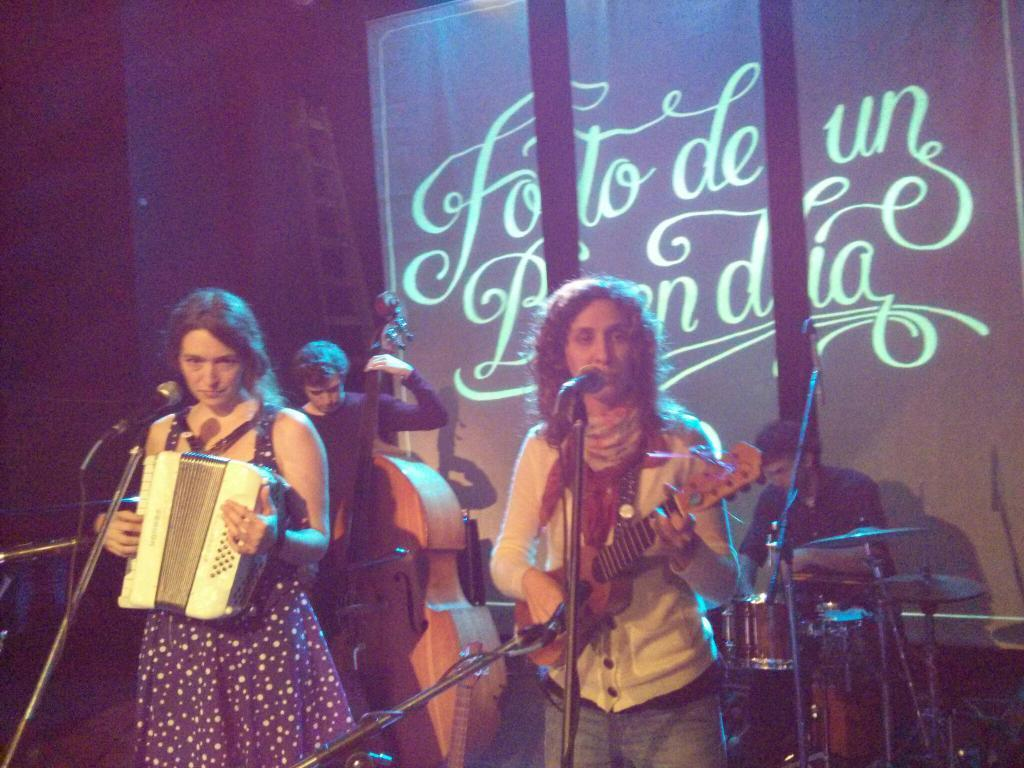How many people are in the image? There are people in the image, but the exact number is not specified. What are the people doing in the image? The people are standing in the image. What are the people holding in their hands? The people are holding musical instruments in their hands. What type of glove can be seen on the person's hand in the image? There is no glove present on any person's hand in the image. What type of substance is being played by the people in the image? The people are holding musical instruments, not a substance, in their hands. 